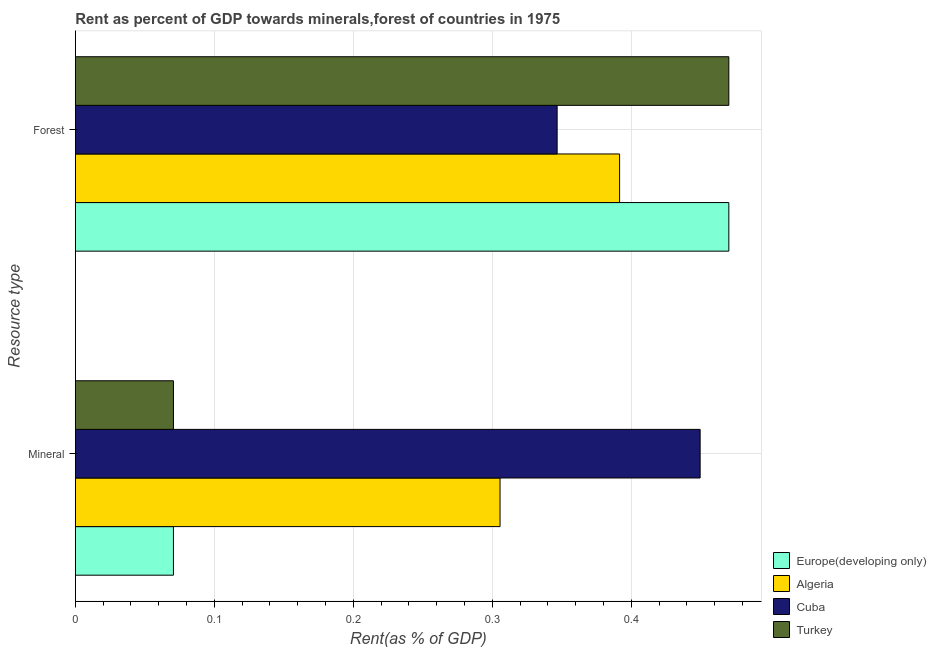How many different coloured bars are there?
Keep it short and to the point. 4. How many groups of bars are there?
Your answer should be very brief. 2. Are the number of bars on each tick of the Y-axis equal?
Ensure brevity in your answer.  Yes. How many bars are there on the 2nd tick from the top?
Ensure brevity in your answer.  4. What is the label of the 1st group of bars from the top?
Offer a very short reply. Forest. What is the mineral rent in Turkey?
Provide a short and direct response. 0.07. Across all countries, what is the maximum mineral rent?
Provide a short and direct response. 0.45. Across all countries, what is the minimum forest rent?
Your answer should be compact. 0.35. In which country was the forest rent maximum?
Ensure brevity in your answer.  Europe(developing only). In which country was the forest rent minimum?
Offer a terse response. Cuba. What is the total mineral rent in the graph?
Provide a short and direct response. 0.9. What is the difference between the mineral rent in Algeria and that in Europe(developing only)?
Provide a short and direct response. 0.23. What is the difference between the mineral rent in Cuba and the forest rent in Europe(developing only)?
Give a very brief answer. -0.02. What is the average forest rent per country?
Your response must be concise. 0.42. What is the difference between the mineral rent and forest rent in Cuba?
Make the answer very short. 0.1. In how many countries, is the forest rent greater than 0.16 %?
Your answer should be very brief. 4. What is the ratio of the forest rent in Cuba to that in Europe(developing only)?
Your answer should be compact. 0.74. Is the mineral rent in Cuba less than that in Europe(developing only)?
Ensure brevity in your answer.  No. What does the 2nd bar from the bottom in Mineral represents?
Your answer should be compact. Algeria. How many bars are there?
Give a very brief answer. 8. Are all the bars in the graph horizontal?
Ensure brevity in your answer.  Yes. Are the values on the major ticks of X-axis written in scientific E-notation?
Make the answer very short. No. Does the graph contain any zero values?
Provide a short and direct response. No. Does the graph contain grids?
Provide a short and direct response. Yes. How many legend labels are there?
Make the answer very short. 4. How are the legend labels stacked?
Your answer should be very brief. Vertical. What is the title of the graph?
Keep it short and to the point. Rent as percent of GDP towards minerals,forest of countries in 1975. Does "China" appear as one of the legend labels in the graph?
Make the answer very short. No. What is the label or title of the X-axis?
Your answer should be very brief. Rent(as % of GDP). What is the label or title of the Y-axis?
Your response must be concise. Resource type. What is the Rent(as % of GDP) in Europe(developing only) in Mineral?
Your response must be concise. 0.07. What is the Rent(as % of GDP) in Algeria in Mineral?
Your answer should be very brief. 0.31. What is the Rent(as % of GDP) in Cuba in Mineral?
Make the answer very short. 0.45. What is the Rent(as % of GDP) in Turkey in Mineral?
Provide a succinct answer. 0.07. What is the Rent(as % of GDP) of Europe(developing only) in Forest?
Give a very brief answer. 0.47. What is the Rent(as % of GDP) in Algeria in Forest?
Provide a succinct answer. 0.39. What is the Rent(as % of GDP) in Cuba in Forest?
Offer a terse response. 0.35. What is the Rent(as % of GDP) of Turkey in Forest?
Keep it short and to the point. 0.47. Across all Resource type, what is the maximum Rent(as % of GDP) of Europe(developing only)?
Provide a succinct answer. 0.47. Across all Resource type, what is the maximum Rent(as % of GDP) in Algeria?
Provide a short and direct response. 0.39. Across all Resource type, what is the maximum Rent(as % of GDP) in Cuba?
Your answer should be compact. 0.45. Across all Resource type, what is the maximum Rent(as % of GDP) in Turkey?
Offer a very short reply. 0.47. Across all Resource type, what is the minimum Rent(as % of GDP) in Europe(developing only)?
Ensure brevity in your answer.  0.07. Across all Resource type, what is the minimum Rent(as % of GDP) of Algeria?
Provide a succinct answer. 0.31. Across all Resource type, what is the minimum Rent(as % of GDP) in Cuba?
Give a very brief answer. 0.35. Across all Resource type, what is the minimum Rent(as % of GDP) in Turkey?
Your response must be concise. 0.07. What is the total Rent(as % of GDP) in Europe(developing only) in the graph?
Offer a very short reply. 0.54. What is the total Rent(as % of GDP) of Algeria in the graph?
Keep it short and to the point. 0.7. What is the total Rent(as % of GDP) in Cuba in the graph?
Offer a terse response. 0.8. What is the total Rent(as % of GDP) of Turkey in the graph?
Provide a succinct answer. 0.54. What is the difference between the Rent(as % of GDP) in Europe(developing only) in Mineral and that in Forest?
Give a very brief answer. -0.4. What is the difference between the Rent(as % of GDP) in Algeria in Mineral and that in Forest?
Your answer should be compact. -0.09. What is the difference between the Rent(as % of GDP) of Cuba in Mineral and that in Forest?
Ensure brevity in your answer.  0.1. What is the difference between the Rent(as % of GDP) in Turkey in Mineral and that in Forest?
Offer a very short reply. -0.4. What is the difference between the Rent(as % of GDP) in Europe(developing only) in Mineral and the Rent(as % of GDP) in Algeria in Forest?
Give a very brief answer. -0.32. What is the difference between the Rent(as % of GDP) in Europe(developing only) in Mineral and the Rent(as % of GDP) in Cuba in Forest?
Ensure brevity in your answer.  -0.28. What is the difference between the Rent(as % of GDP) of Europe(developing only) in Mineral and the Rent(as % of GDP) of Turkey in Forest?
Make the answer very short. -0.4. What is the difference between the Rent(as % of GDP) of Algeria in Mineral and the Rent(as % of GDP) of Cuba in Forest?
Ensure brevity in your answer.  -0.04. What is the difference between the Rent(as % of GDP) in Algeria in Mineral and the Rent(as % of GDP) in Turkey in Forest?
Ensure brevity in your answer.  -0.16. What is the difference between the Rent(as % of GDP) of Cuba in Mineral and the Rent(as % of GDP) of Turkey in Forest?
Your answer should be compact. -0.02. What is the average Rent(as % of GDP) of Europe(developing only) per Resource type?
Give a very brief answer. 0.27. What is the average Rent(as % of GDP) of Algeria per Resource type?
Keep it short and to the point. 0.35. What is the average Rent(as % of GDP) of Cuba per Resource type?
Give a very brief answer. 0.4. What is the average Rent(as % of GDP) of Turkey per Resource type?
Provide a succinct answer. 0.27. What is the difference between the Rent(as % of GDP) in Europe(developing only) and Rent(as % of GDP) in Algeria in Mineral?
Ensure brevity in your answer.  -0.23. What is the difference between the Rent(as % of GDP) of Europe(developing only) and Rent(as % of GDP) of Cuba in Mineral?
Make the answer very short. -0.38. What is the difference between the Rent(as % of GDP) of Europe(developing only) and Rent(as % of GDP) of Turkey in Mineral?
Make the answer very short. 0. What is the difference between the Rent(as % of GDP) of Algeria and Rent(as % of GDP) of Cuba in Mineral?
Give a very brief answer. -0.14. What is the difference between the Rent(as % of GDP) in Algeria and Rent(as % of GDP) in Turkey in Mineral?
Offer a very short reply. 0.23. What is the difference between the Rent(as % of GDP) of Cuba and Rent(as % of GDP) of Turkey in Mineral?
Make the answer very short. 0.38. What is the difference between the Rent(as % of GDP) in Europe(developing only) and Rent(as % of GDP) in Algeria in Forest?
Provide a short and direct response. 0.08. What is the difference between the Rent(as % of GDP) of Europe(developing only) and Rent(as % of GDP) of Cuba in Forest?
Keep it short and to the point. 0.12. What is the difference between the Rent(as % of GDP) in Europe(developing only) and Rent(as % of GDP) in Turkey in Forest?
Ensure brevity in your answer.  0. What is the difference between the Rent(as % of GDP) in Algeria and Rent(as % of GDP) in Cuba in Forest?
Give a very brief answer. 0.04. What is the difference between the Rent(as % of GDP) in Algeria and Rent(as % of GDP) in Turkey in Forest?
Ensure brevity in your answer.  -0.08. What is the difference between the Rent(as % of GDP) of Cuba and Rent(as % of GDP) of Turkey in Forest?
Your response must be concise. -0.12. What is the ratio of the Rent(as % of GDP) of Europe(developing only) in Mineral to that in Forest?
Your answer should be compact. 0.15. What is the ratio of the Rent(as % of GDP) in Algeria in Mineral to that in Forest?
Your answer should be compact. 0.78. What is the ratio of the Rent(as % of GDP) of Cuba in Mineral to that in Forest?
Your answer should be compact. 1.3. What is the ratio of the Rent(as % of GDP) in Turkey in Mineral to that in Forest?
Offer a terse response. 0.15. What is the difference between the highest and the second highest Rent(as % of GDP) in Europe(developing only)?
Ensure brevity in your answer.  0.4. What is the difference between the highest and the second highest Rent(as % of GDP) in Algeria?
Your answer should be compact. 0.09. What is the difference between the highest and the second highest Rent(as % of GDP) in Cuba?
Offer a terse response. 0.1. What is the difference between the highest and the second highest Rent(as % of GDP) in Turkey?
Your answer should be very brief. 0.4. What is the difference between the highest and the lowest Rent(as % of GDP) in Europe(developing only)?
Make the answer very short. 0.4. What is the difference between the highest and the lowest Rent(as % of GDP) in Algeria?
Your answer should be compact. 0.09. What is the difference between the highest and the lowest Rent(as % of GDP) in Cuba?
Offer a very short reply. 0.1. What is the difference between the highest and the lowest Rent(as % of GDP) of Turkey?
Keep it short and to the point. 0.4. 